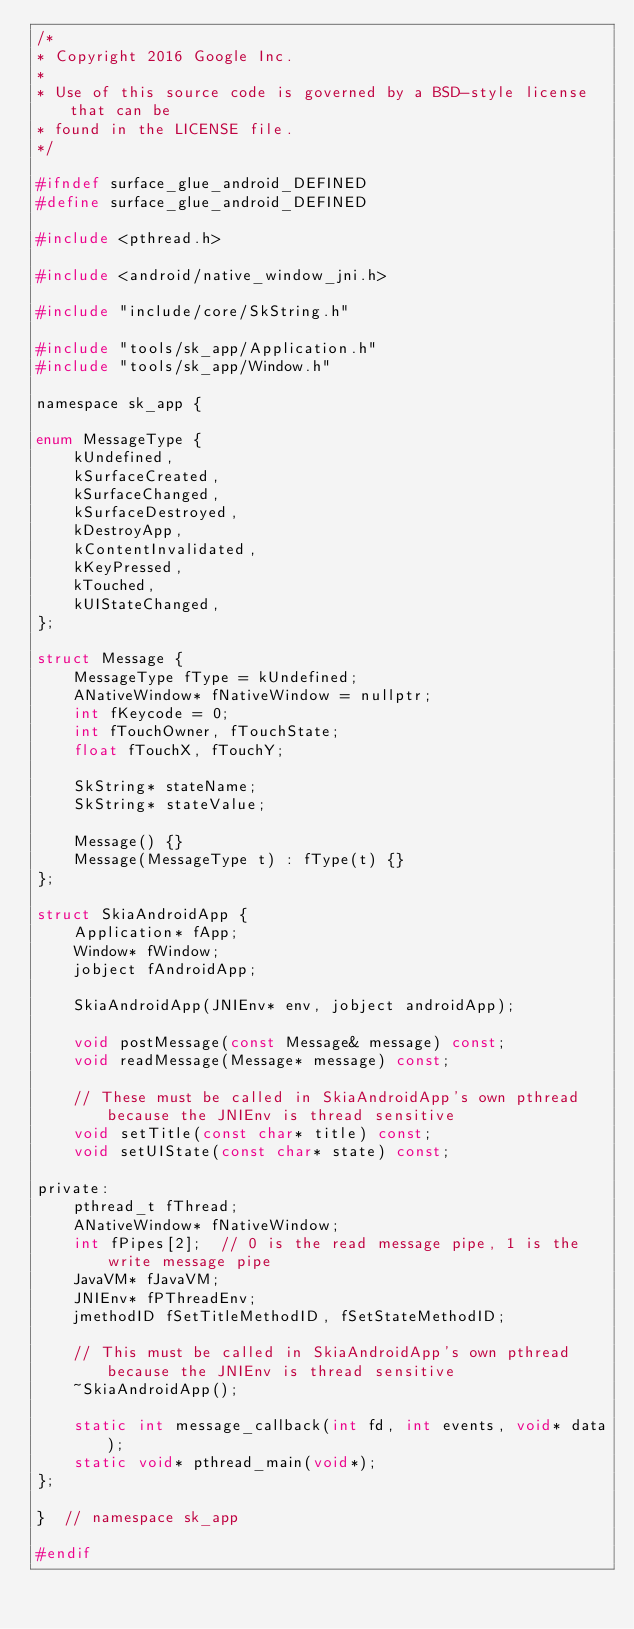<code> <loc_0><loc_0><loc_500><loc_500><_C_>/*
* Copyright 2016 Google Inc.
*
* Use of this source code is governed by a BSD-style license that can be
* found in the LICENSE file.
*/

#ifndef surface_glue_android_DEFINED
#define surface_glue_android_DEFINED

#include <pthread.h>

#include <android/native_window_jni.h>

#include "include/core/SkString.h"

#include "tools/sk_app/Application.h"
#include "tools/sk_app/Window.h"

namespace sk_app {

enum MessageType {
    kUndefined,
    kSurfaceCreated,
    kSurfaceChanged,
    kSurfaceDestroyed,
    kDestroyApp,
    kContentInvalidated,
    kKeyPressed,
    kTouched,
    kUIStateChanged,
};

struct Message {
    MessageType fType = kUndefined;
    ANativeWindow* fNativeWindow = nullptr;
    int fKeycode = 0;
    int fTouchOwner, fTouchState;
    float fTouchX, fTouchY;

    SkString* stateName;
    SkString* stateValue;

    Message() {}
    Message(MessageType t) : fType(t) {}
};

struct SkiaAndroidApp {
    Application* fApp;
    Window* fWindow;
    jobject fAndroidApp;

    SkiaAndroidApp(JNIEnv* env, jobject androidApp);

    void postMessage(const Message& message) const;
    void readMessage(Message* message) const;

    // These must be called in SkiaAndroidApp's own pthread because the JNIEnv is thread sensitive
    void setTitle(const char* title) const;
    void setUIState(const char* state) const;

private:
    pthread_t fThread;
    ANativeWindow* fNativeWindow;
    int fPipes[2];  // 0 is the read message pipe, 1 is the write message pipe
    JavaVM* fJavaVM;
    JNIEnv* fPThreadEnv;
    jmethodID fSetTitleMethodID, fSetStateMethodID;

    // This must be called in SkiaAndroidApp's own pthread because the JNIEnv is thread sensitive
    ~SkiaAndroidApp();

    static int message_callback(int fd, int events, void* data);
    static void* pthread_main(void*);
};

}  // namespace sk_app

#endif
</code> 